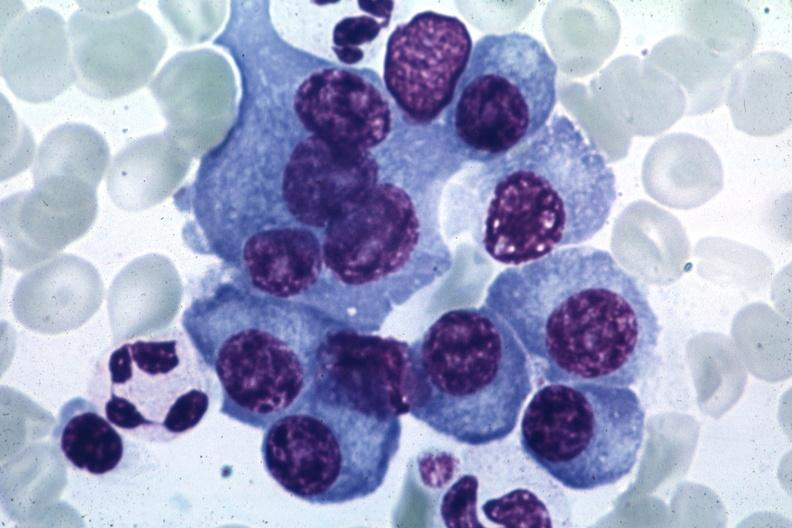s nodular tumor present?
Answer the question using a single word or phrase. No 